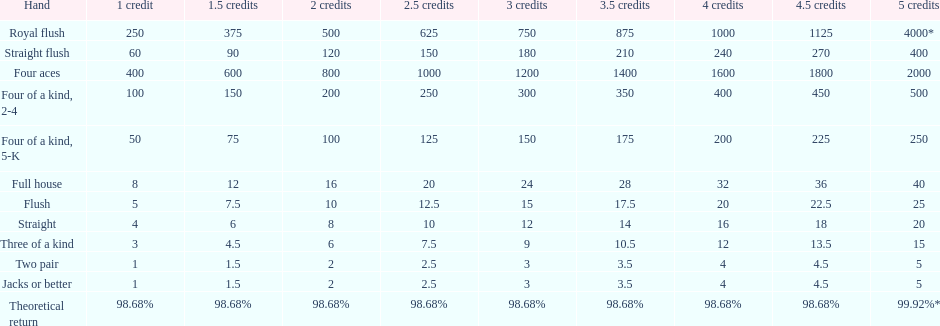How many straight wins at 3 credits equals one straight flush win at two credits? 10. 